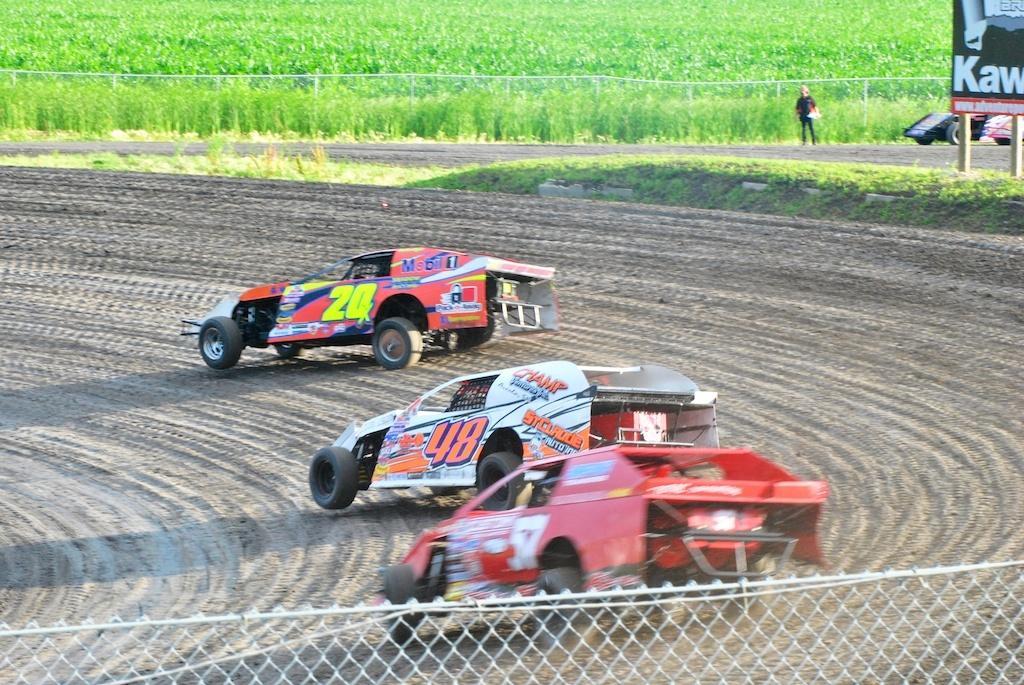Can you describe this image briefly? In the center of the image we can see cars on the plow land. At the bottom there is a fence. In the background there are fields. On the right there is a lady standing and we can see a board. 